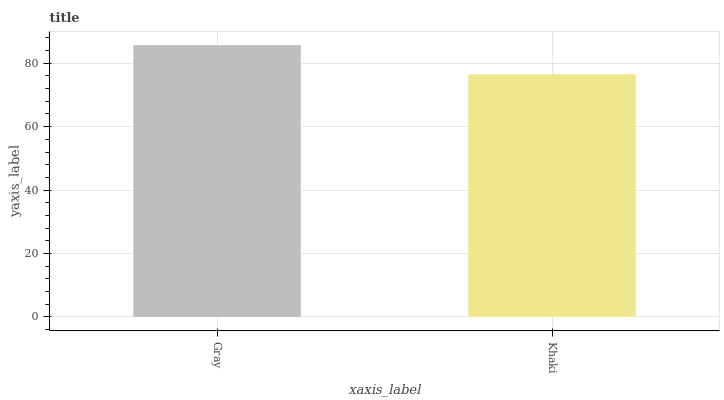Is Khaki the minimum?
Answer yes or no. Yes. Is Gray the maximum?
Answer yes or no. Yes. Is Khaki the maximum?
Answer yes or no. No. Is Gray greater than Khaki?
Answer yes or no. Yes. Is Khaki less than Gray?
Answer yes or no. Yes. Is Khaki greater than Gray?
Answer yes or no. No. Is Gray less than Khaki?
Answer yes or no. No. Is Gray the high median?
Answer yes or no. Yes. Is Khaki the low median?
Answer yes or no. Yes. Is Khaki the high median?
Answer yes or no. No. Is Gray the low median?
Answer yes or no. No. 